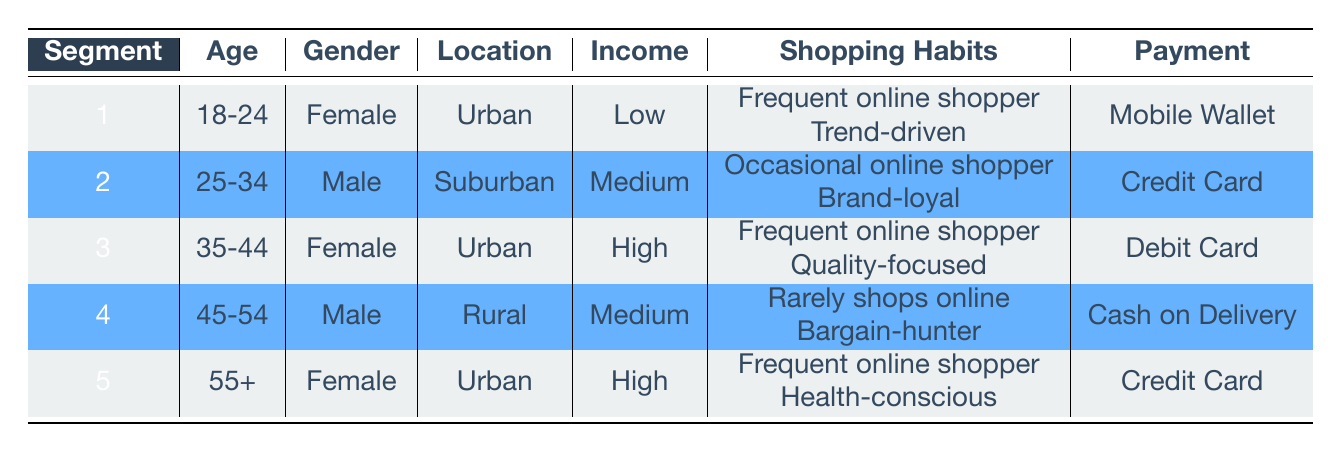What is the preferred payment method for the segment aged 18-24? The table indicates that for segment 1, which corresponds to the age group 18-24, the preferred payment method is a Mobile Wallet.
Answer: Mobile Wallet How many segments are there that are Female? From the table, we can identify three segments that are Female: segment 1 (age 18-24), segment 3 (age 35-44), and segment 5 (age 55+). Therefore, the count is 3.
Answer: 3 What is the average income level among the segments? The income levels represented in the table are: Low (segment 1), Medium (segments 2 and 4), and High (segments 3 and 5). Assigning numerical values, we can consider Low=1, Medium=2, and High=3. The sum is 1 + 2 + 2 + 2 + 3 = 10, and with 5 segments, the average income level is 10/5 = 2, which corresponds to Medium.
Answer: Medium Is segment 4 a frequent online shopper? The shopping habits of segment 4 indicate that they "rarely shops online," which is a clear indication that the statement is false.
Answer: No What is the total number of segments located in Urban areas? By examining the table, we see that segments 1 (age 18-24), 3 (age 35-44), and 5 (age 55+) are all located in Urban areas, resulting in a total of 3 segments.
Answer: 3 What is the income level of the segment with shopping habits focused on quality? Segment 3 has shopping habits that include being "Quality-focused," and according to the table, this segment has a High income level.
Answer: High Do all segments with High income prefer Credit Cards as their payment method? The table demonstrates that segment 3 (High income) prefers Debit Card, while segment 5 (also High income) prefers Credit Card. Therefore, not all High income segments prefer Credit Cards.
Answer: No Which gender is more prevalent in Urban locations? The table shows that segments located in Urban areas are segment 1 (Female), segment 3 (Female), and segment 5 (Female), while segment 2 (Male) is in Suburban, and segment 4 (Male) is in Rural. Thus, Females dominate Urban locations with 3 segments against 0 Males.
Answer: Female What percentage of segments are identified as bargain-hunters? The table indicates that only segment 4 has the shopping habit of being a "Bargain-hunter." With 5 total segments, the percentage of bargain-hunters is (1/5) * 100 = 20%.
Answer: 20% 